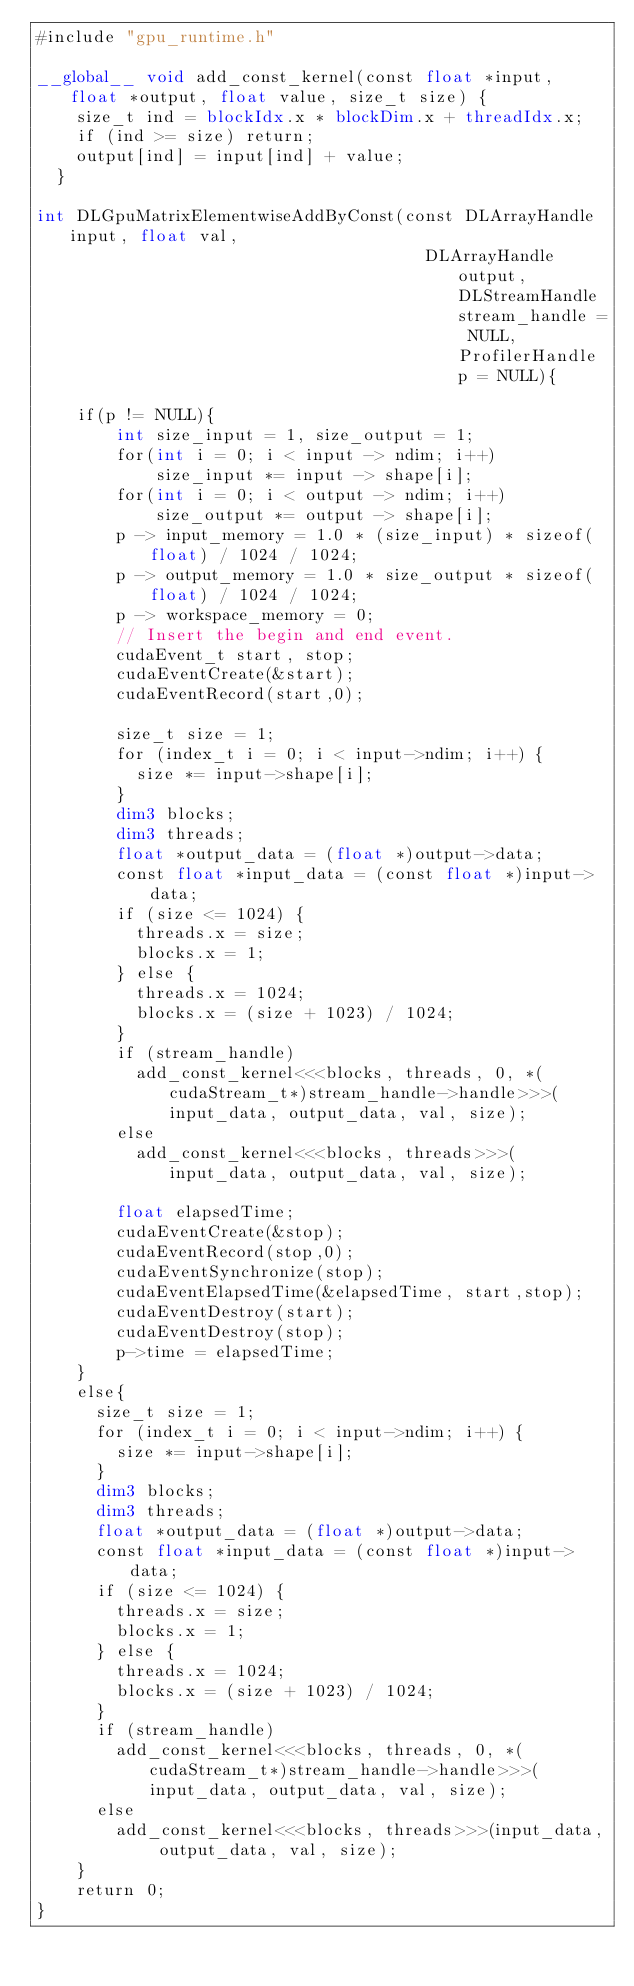Convert code to text. <code><loc_0><loc_0><loc_500><loc_500><_Cuda_>#include "gpu_runtime.h"

__global__ void add_const_kernel(const float *input, float *output, float value, size_t size) {
    size_t ind = blockIdx.x * blockDim.x + threadIdx.x;
    if (ind >= size) return;
    output[ind] = input[ind] + value;
  }
  
int DLGpuMatrixElementwiseAddByConst(const DLArrayHandle input, float val,
                                       DLArrayHandle output, DLStreamHandle stream_handle = NULL, ProfilerHandle p = NULL){
                                           
    if(p != NULL){
        int size_input = 1, size_output = 1;
        for(int i = 0; i < input -> ndim; i++)
            size_input *= input -> shape[i];
        for(int i = 0; i < output -> ndim; i++)
            size_output *= output -> shape[i];
        p -> input_memory = 1.0 * (size_input) * sizeof(float) / 1024 / 1024;
        p -> output_memory = 1.0 * size_output * sizeof(float) / 1024 / 1024;
        p -> workspace_memory = 0;
        // Insert the begin and end event.
        cudaEvent_t start, stop;
        cudaEventCreate(&start);
        cudaEventRecord(start,0);

        size_t size = 1;
        for (index_t i = 0; i < input->ndim; i++) {
          size *= input->shape[i];
        }
        dim3 blocks;
        dim3 threads;
        float *output_data = (float *)output->data;
        const float *input_data = (const float *)input->data;
        if (size <= 1024) {
          threads.x = size;
          blocks.x = 1;
        } else {
          threads.x = 1024;
          blocks.x = (size + 1023) / 1024;
        }
        if (stream_handle)
          add_const_kernel<<<blocks, threads, 0, *(cudaStream_t*)stream_handle->handle>>>(input_data, output_data, val, size);
        else
          add_const_kernel<<<blocks, threads>>>(input_data, output_data, val, size);

        float elapsedTime;
        cudaEventCreate(&stop);
        cudaEventRecord(stop,0);
        cudaEventSynchronize(stop);
        cudaEventElapsedTime(&elapsedTime, start,stop);
        cudaEventDestroy(start);
        cudaEventDestroy(stop);
        p->time = elapsedTime;
    }
    else{
      size_t size = 1;
      for (index_t i = 0; i < input->ndim; i++) {
        size *= input->shape[i];
      }
      dim3 blocks;
      dim3 threads;
      float *output_data = (float *)output->data;
      const float *input_data = (const float *)input->data;
      if (size <= 1024) {
        threads.x = size;
        blocks.x = 1;
      } else {
        threads.x = 1024;
        blocks.x = (size + 1023) / 1024;
      }
      if (stream_handle)
        add_const_kernel<<<blocks, threads, 0, *(cudaStream_t*)stream_handle->handle>>>(input_data, output_data, val, size);
      else
        add_const_kernel<<<blocks, threads>>>(input_data, output_data, val, size);
    }
    return 0;
}</code> 